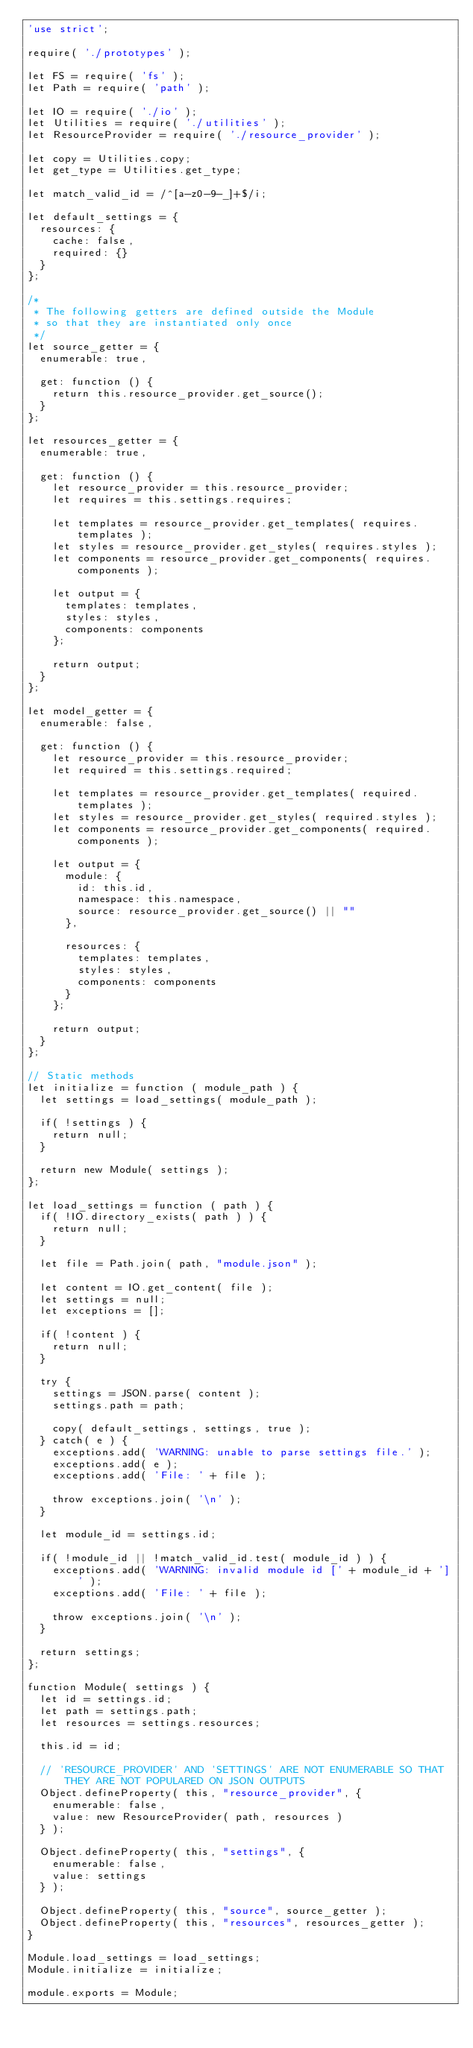<code> <loc_0><loc_0><loc_500><loc_500><_JavaScript_>'use strict';

require( './prototypes' );

let FS = require( 'fs' );
let Path = require( 'path' );

let IO = require( './io' );
let Utilities = require( './utilities' );
let ResourceProvider = require( './resource_provider' );

let copy = Utilities.copy;
let get_type = Utilities.get_type;

let match_valid_id = /^[a-z0-9-_]+$/i;

let default_settings = {
	resources: {
		cache: false,
		required: {}
	}
};

/*
 * The following getters are defined outside the Module
 * so that they are instantiated only once
 */
let source_getter = {
	enumerable: true,

	get: function () {
		return this.resource_provider.get_source();
	}
};

let resources_getter = {
	enumerable: true,

	get: function () {
		let resource_provider = this.resource_provider;
		let requires = this.settings.requires;

		let templates = resource_provider.get_templates( requires.templates );
		let styles = resource_provider.get_styles( requires.styles );
		let components = resource_provider.get_components( requires.components );

		let output = {
			templates: templates,
			styles: styles,
			components: components
		};

		return output;
	}
};

let model_getter = {
	enumerable: false,

	get: function () {
		let resource_provider = this.resource_provider;
		let required = this.settings.required;

		let templates = resource_provider.get_templates( required.templates );
		let styles = resource_provider.get_styles( required.styles );
		let components = resource_provider.get_components( required.components );

		let output = {
			module: {
				id: this.id,
				namespace: this.namespace,
				source: resource_provider.get_source() || ""
			},

			resources: {
				templates: templates,
				styles: styles,
				components: components
			}
		};

		return output;
	}
};

// Static methods
let initialize = function ( module_path ) {
	let settings = load_settings( module_path );

	if( !settings ) {
		return null;
	}

	return new Module( settings );
};

let load_settings = function ( path ) {
	if( !IO.directory_exists( path ) ) {
		return null;
	}

	let file = Path.join( path, "module.json" );

	let content = IO.get_content( file );
	let settings = null;
	let exceptions = [];

	if( !content ) {
		return null;
	}

	try {
		settings = JSON.parse( content );
		settings.path = path;

		copy( default_settings, settings, true );
	} catch( e ) {
		exceptions.add( 'WARNING: unable to parse settings file.' );
		exceptions.add( e );
		exceptions.add( 'File: ' + file );

		throw exceptions.join( '\n' );
	}

	let module_id = settings.id;

	if( !module_id || !match_valid_id.test( module_id ) ) {
		exceptions.add( 'WARNING: invalid module id [' + module_id + ']' );
		exceptions.add( 'File: ' + file );

		throw exceptions.join( '\n' );
	}

	return settings;
};

function Module( settings ) {
	let id = settings.id;
	let path = settings.path;
	let resources = settings.resources;

	this.id = id;

	// 'RESOURCE_PROVIDER' AND 'SETTINGS' ARE NOT ENUMERABLE SO THAT THEY ARE NOT POPULARED ON JSON OUTPUTS
	Object.defineProperty( this, "resource_provider", {
		enumerable: false,
		value: new ResourceProvider( path, resources )
	} );

	Object.defineProperty( this, "settings", {
		enumerable: false,
		value: settings
	} );

	Object.defineProperty( this, "source", source_getter );
	Object.defineProperty( this, "resources", resources_getter );
}

Module.load_settings = load_settings;
Module.initialize = initialize;

module.exports = Module;</code> 